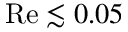Convert formula to latex. <formula><loc_0><loc_0><loc_500><loc_500>R e \lesssim 0 . 0 5</formula> 